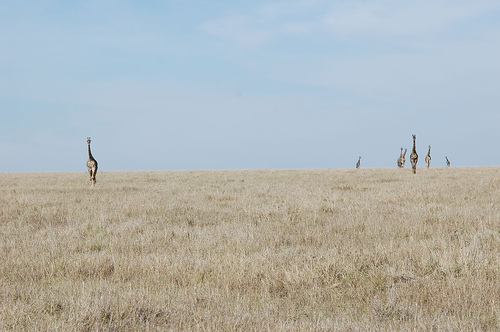<image>What keeps the animals from getting close to the camera? It is unknown what keeps the animals from getting close to the camera. It could be a variety of factors such as distance, fear of humans, or other impediments. What keeps the animals from getting close to the camera? I don't know what keeps the animals from getting close to the camera. It can be nothing, or they might be scared of humans or prefer to stay at a distance. 